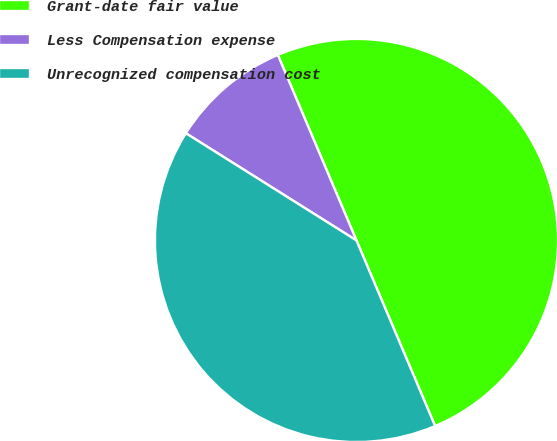Convert chart. <chart><loc_0><loc_0><loc_500><loc_500><pie_chart><fcel>Grant-date fair value<fcel>Less Compensation expense<fcel>Unrecognized compensation cost<nl><fcel>50.0%<fcel>9.69%<fcel>40.31%<nl></chart> 